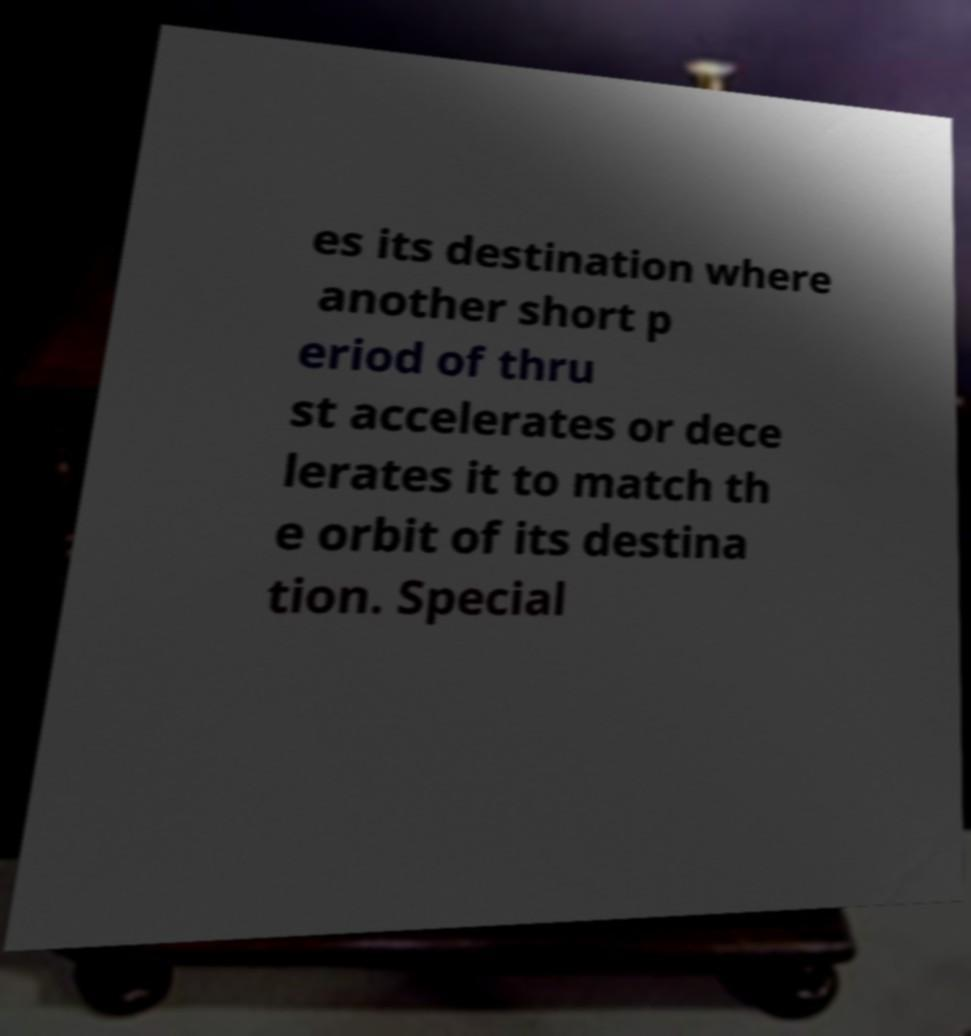What messages or text are displayed in this image? I need them in a readable, typed format. es its destination where another short p eriod of thru st accelerates or dece lerates it to match th e orbit of its destina tion. Special 